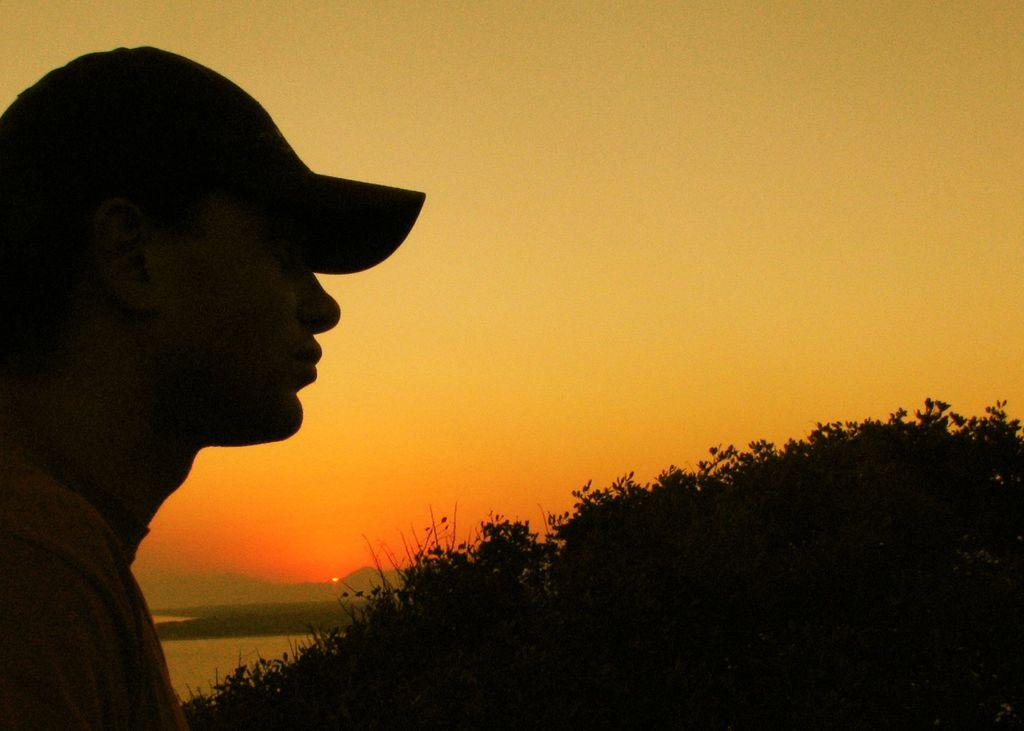What is located on the left side of the image? There is a person wearing a cap on the left side of the image. What type of vegetation is on the right side of the image? There are trees on the right side of the image. What can be seen in the background of the image? The sky, the sun, hills, and water are visible in the background of the image. What type of table is visible in the image? There is no table present in the image. How many boundaries can be seen in the image? There are no boundaries depicted in the image. 